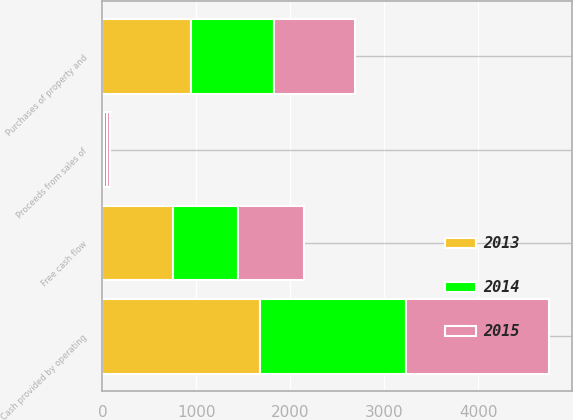<chart> <loc_0><loc_0><loc_500><loc_500><stacked_bar_chart><ecel><fcel>Cash provided by operating<fcel>Purchases of property and<fcel>Proceeds from sales of<fcel>Free cash flow<nl><fcel>2013<fcel>1679.7<fcel>945.6<fcel>21.2<fcel>755.3<nl><fcel>2015<fcel>1529.8<fcel>862.5<fcel>35.7<fcel>703<nl><fcel>2014<fcel>1548.2<fcel>880.8<fcel>23.9<fcel>691.3<nl></chart> 